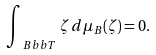<formula> <loc_0><loc_0><loc_500><loc_500>\int _ { \ B b b T } \, \zeta \, d \mu _ { B } ( \zeta ) = 0 .</formula> 